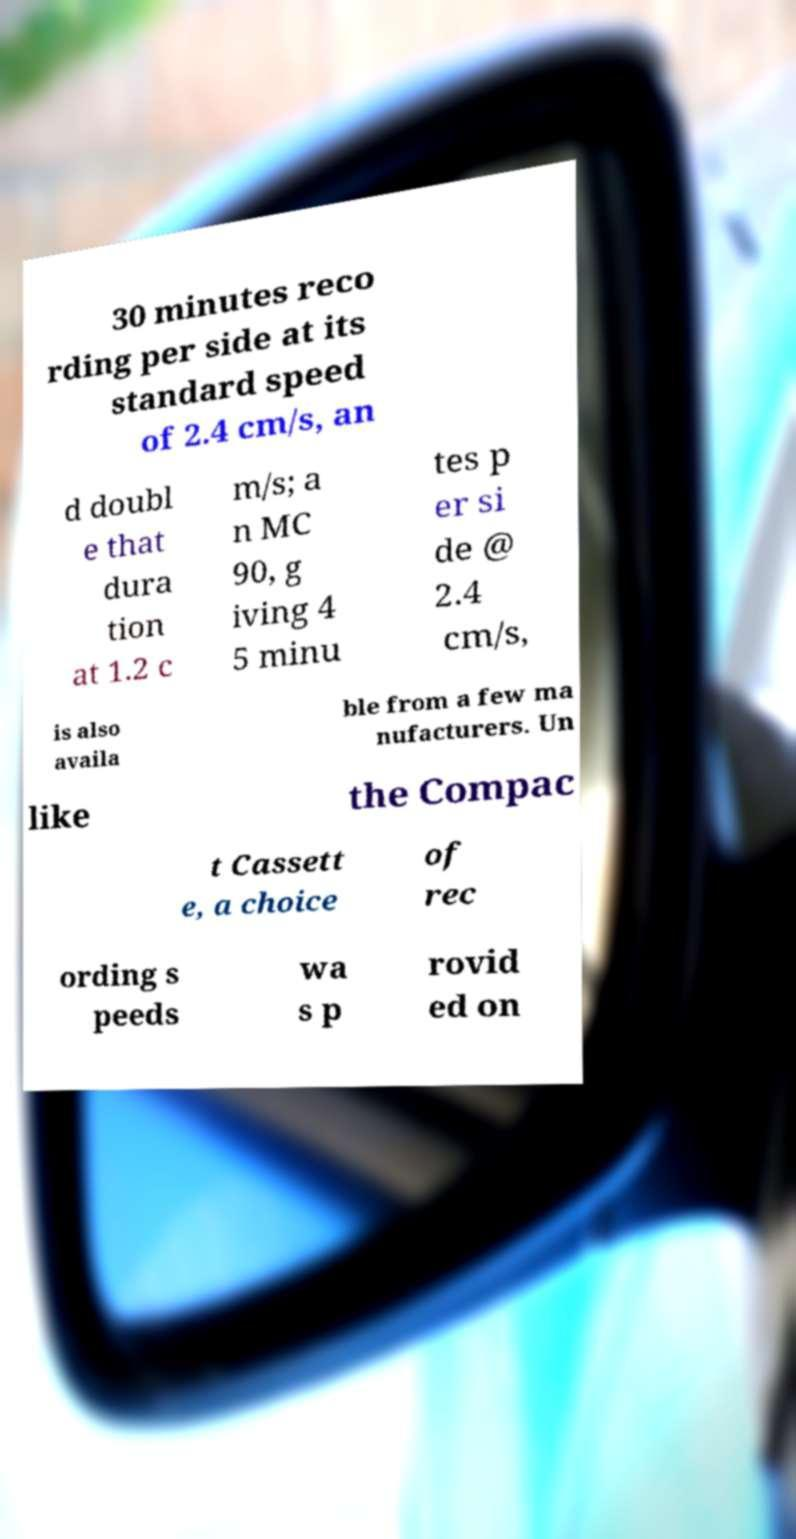For documentation purposes, I need the text within this image transcribed. Could you provide that? 30 minutes reco rding per side at its standard speed of 2.4 cm/s, an d doubl e that dura tion at 1.2 c m/s; a n MC 90, g iving 4 5 minu tes p er si de @ 2.4 cm/s, is also availa ble from a few ma nufacturers. Un like the Compac t Cassett e, a choice of rec ording s peeds wa s p rovid ed on 